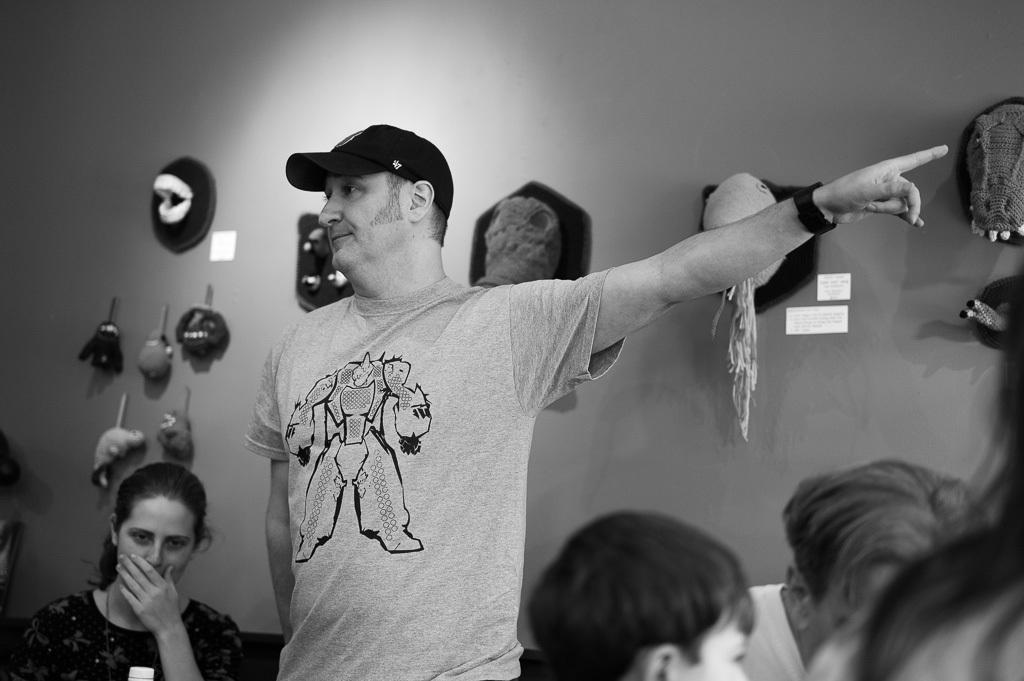What is the color scheme of the image? The image is black and white. Can you describe the subjects in the image? There are people in the image. What can be seen in the background of the image? There is a wall in the background of the image. What is attached to or hanging on the wall? There are objects hanging and attached to the wall. How many fingers can be seen on the worm in the image? There is no worm present in the image, and therefore no fingers can be observed on a worm. 